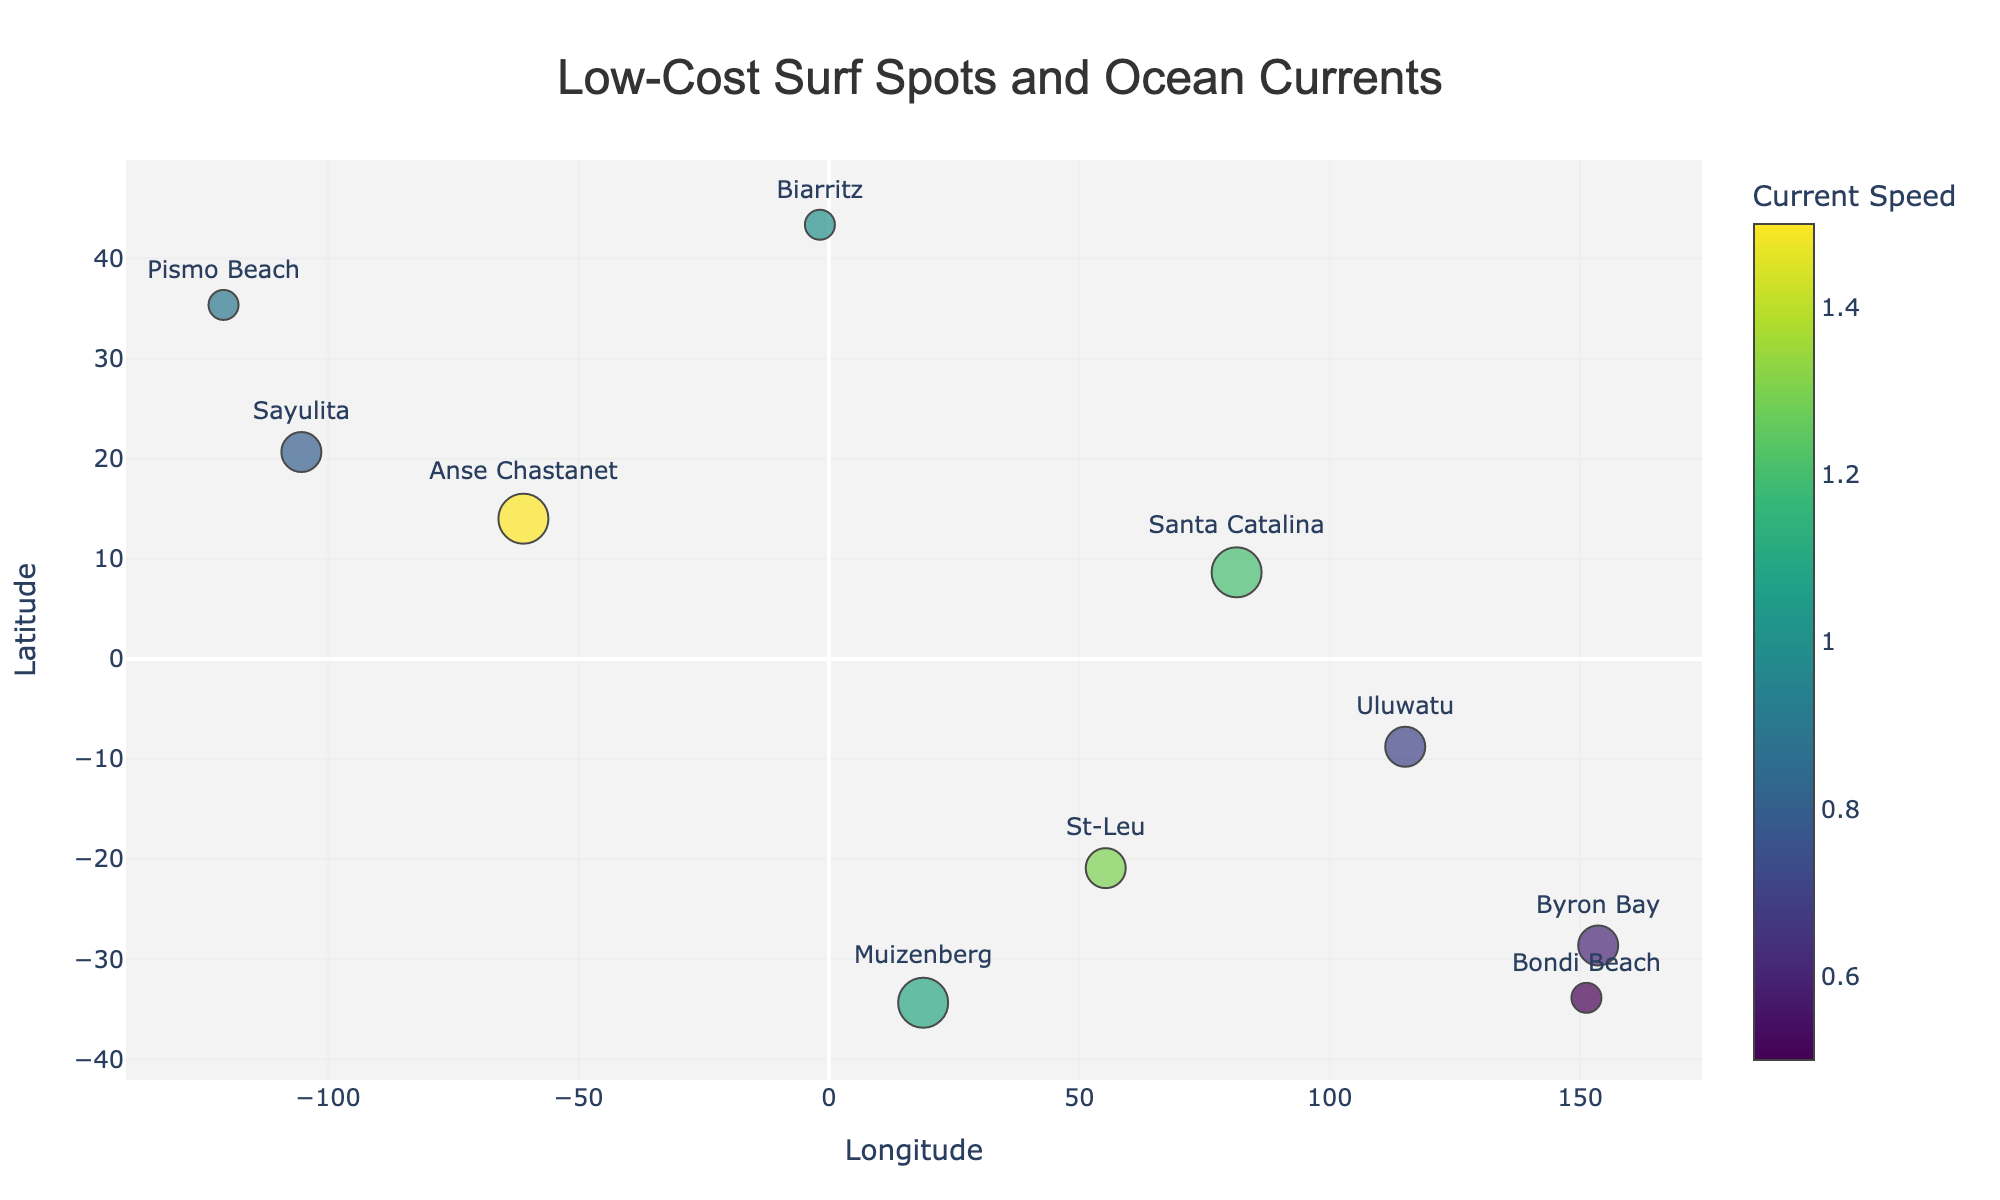What is the title of the plot? The title of the plot is displayed prominently at the top and reads "Low-Cost Surf Spots and Ocean Currents".
Answer: Low-Cost Surf Spots and Ocean Currents How many surf spots are plotted on the figure? By counting the number of markers on the figure, we can see that there are 10 surf spots plotted.
Answer: 10 Which surf spot has the highest budget rating? By observing the size of the circles, and confirming with the hover text, we can see that "Santa Catalina", "Anse Chastanet", and "Muizenberg" all have the highest budget rating of 5.
Answer: Santa Catalina, Anse Chastanet, Muizenberg What is the current speed at Biarritz? The hover text on the point labeled "Biarritz" on the plot shows the current speed as 1.0 knots.
Answer: 1.0 knots Which surf spot has the slowest ocean current? By analyzing the color scale and confirming the hover text, the slowest current speed of 0.5 knots is at "Bondi Beach".
Answer: Bondi Beach Which surf spot has an ocean current direction of 270 degrees? By looking at the hover text, "Sayulita" and "Pismo Beach" both have a current direction of 270 degrees.
Answer: Sayulita, Pismo Beach What is the average current speed of surf spots with a budget rating of 4? Surf spots with a budget rating of 4 include "Sayulita", "Uluwatu", "Byron Bay", and "St-Leu". Their current speeds are 0.8, 0.7, 0.6, and 1.3 knots respectively. The average current speed is (0.8 + 0.7 + 0.6 + 1.3) / 4 = 3.4 / 4 = 0.85 knots.
Answer: 0.85 knots Which surf spot has an ocean current affecting it from the southeast direction? A current direction from the southeast is at approximately 135 degrees. Looking at the hover texts, "Anse Chastanet" has a current direction of 135 degrees.
Answer: Anse Chastanet 